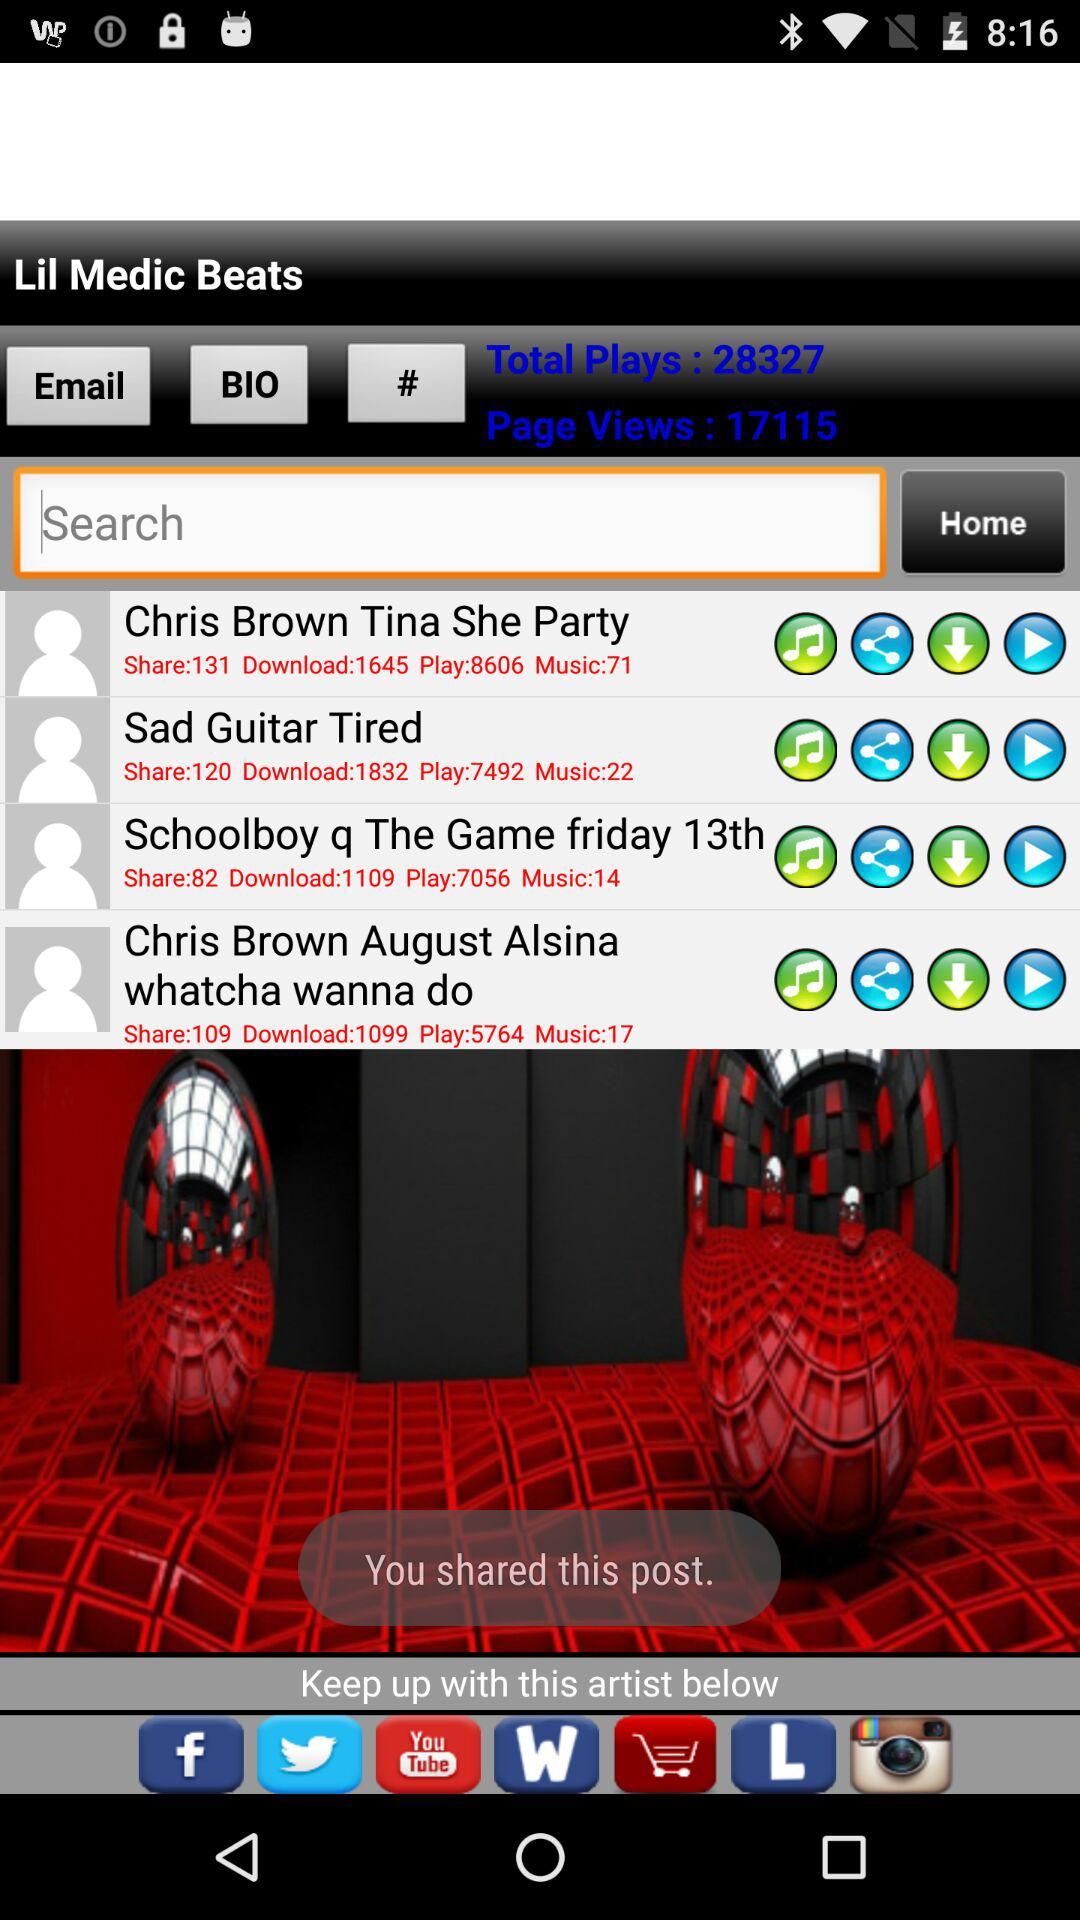What's the number of downloads for "Chris Brown Tina She Party"? The number of downloads is 1645. 